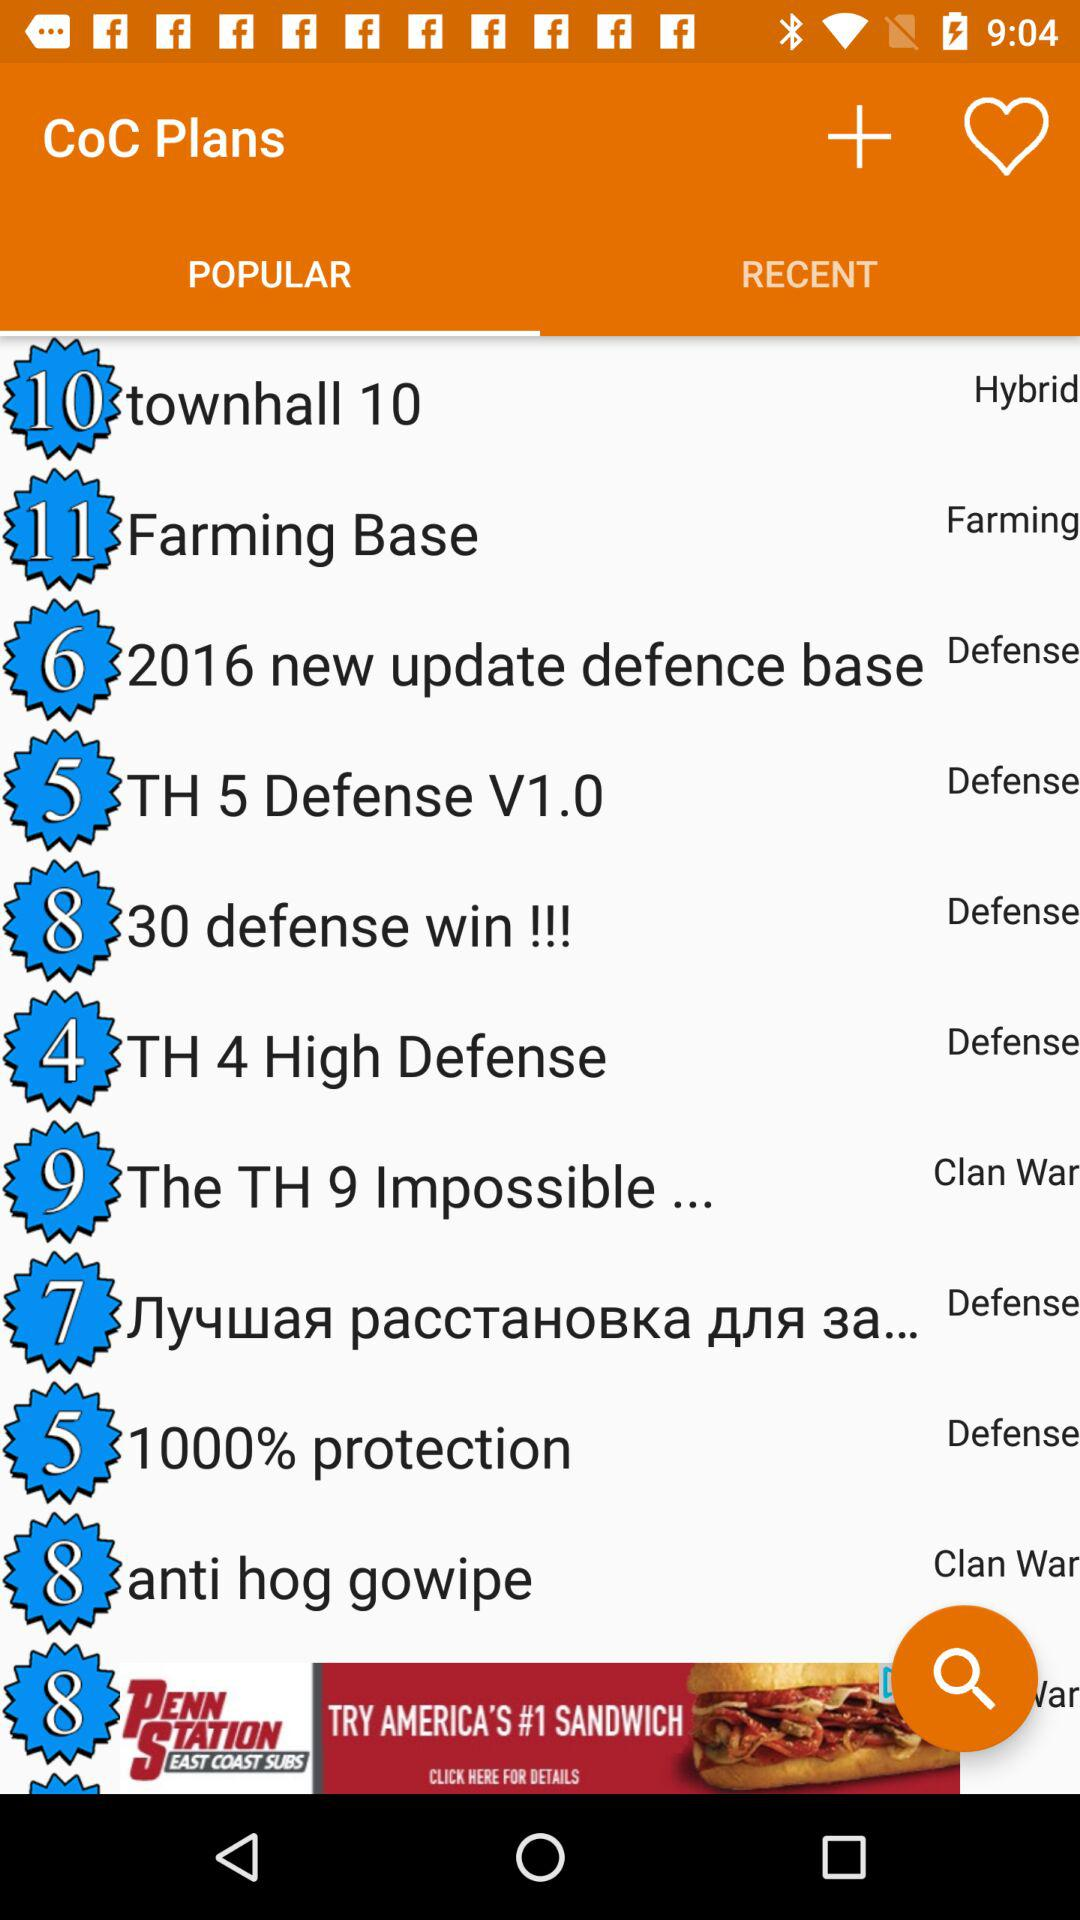Which type of plan does "TH 5 Defense V1.0" fit into? The type of plan that "TH 5 Defense V1.0" fits into is "Defense". 